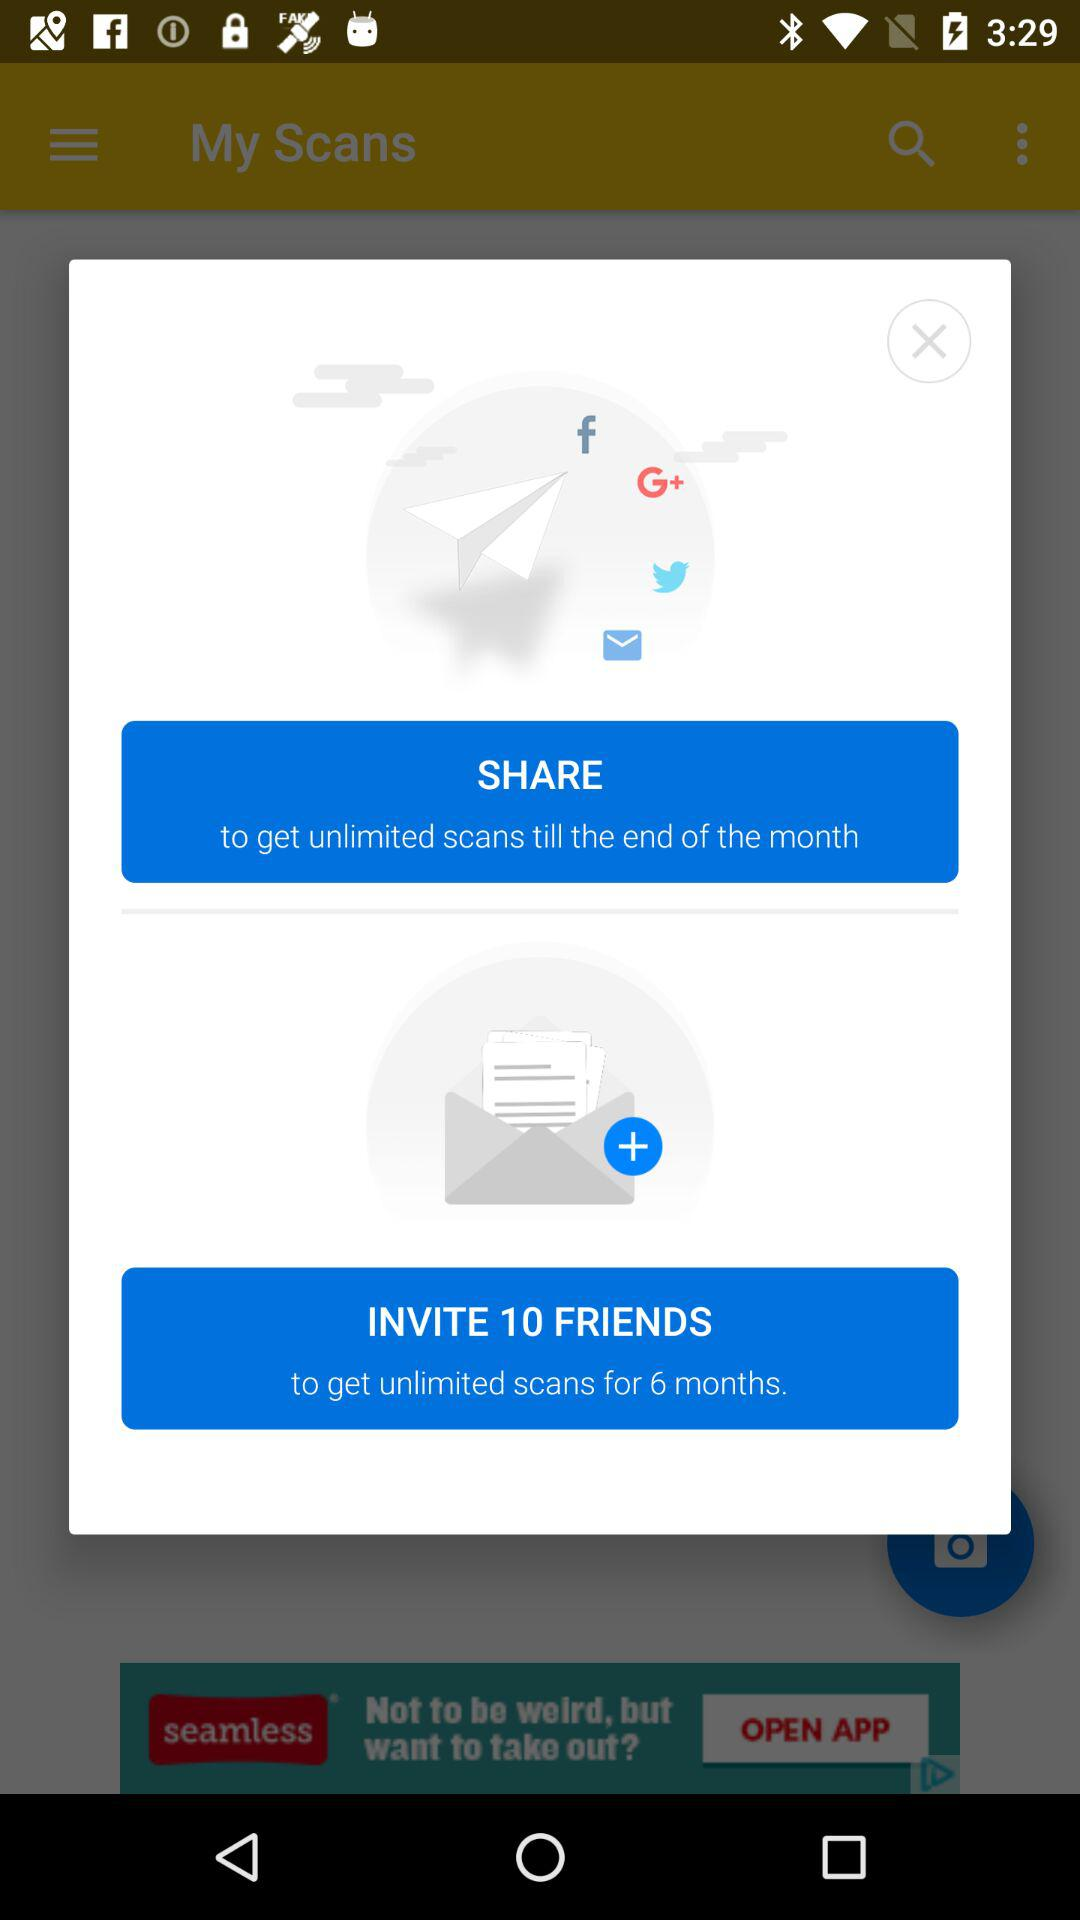How many invites need to be sent for unlimited scans? The invites that need to be sent for unlimited scans are 10. 